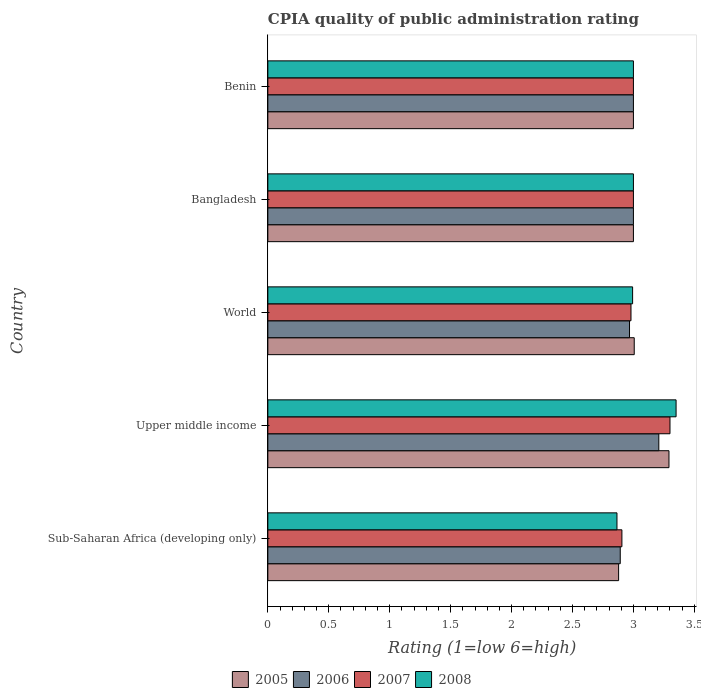Are the number of bars per tick equal to the number of legend labels?
Give a very brief answer. Yes. How many bars are there on the 5th tick from the bottom?
Offer a very short reply. 4. What is the label of the 4th group of bars from the top?
Give a very brief answer. Upper middle income. What is the CPIA rating in 2008 in Sub-Saharan Africa (developing only)?
Offer a terse response. 2.86. Across all countries, what is the maximum CPIA rating in 2005?
Your answer should be very brief. 3.29. Across all countries, what is the minimum CPIA rating in 2008?
Ensure brevity in your answer.  2.86. In which country was the CPIA rating in 2008 maximum?
Ensure brevity in your answer.  Upper middle income. In which country was the CPIA rating in 2005 minimum?
Provide a succinct answer. Sub-Saharan Africa (developing only). What is the total CPIA rating in 2008 in the graph?
Your answer should be compact. 15.21. What is the difference between the CPIA rating in 2005 in Bangladesh and that in Sub-Saharan Africa (developing only)?
Make the answer very short. 0.12. What is the difference between the CPIA rating in 2005 in Sub-Saharan Africa (developing only) and the CPIA rating in 2006 in Benin?
Give a very brief answer. -0.12. What is the average CPIA rating in 2005 per country?
Make the answer very short. 3.04. What is the difference between the CPIA rating in 2006 and CPIA rating in 2008 in Bangladesh?
Offer a very short reply. 0. What is the ratio of the CPIA rating in 2005 in Bangladesh to that in World?
Keep it short and to the point. 1. What is the difference between the highest and the second highest CPIA rating in 2005?
Your answer should be compact. 0.29. What is the difference between the highest and the lowest CPIA rating in 2007?
Keep it short and to the point. 0.39. In how many countries, is the CPIA rating in 2006 greater than the average CPIA rating in 2006 taken over all countries?
Give a very brief answer. 1. Is it the case that in every country, the sum of the CPIA rating in 2008 and CPIA rating in 2007 is greater than the sum of CPIA rating in 2005 and CPIA rating in 2006?
Keep it short and to the point. No. What does the 3rd bar from the bottom in Benin represents?
Give a very brief answer. 2007. Are all the bars in the graph horizontal?
Your answer should be very brief. Yes. How many countries are there in the graph?
Ensure brevity in your answer.  5. Does the graph contain grids?
Give a very brief answer. No. How are the legend labels stacked?
Provide a short and direct response. Horizontal. What is the title of the graph?
Provide a short and direct response. CPIA quality of public administration rating. What is the label or title of the X-axis?
Offer a terse response. Rating (1=low 6=high). What is the label or title of the Y-axis?
Offer a terse response. Country. What is the Rating (1=low 6=high) of 2005 in Sub-Saharan Africa (developing only)?
Make the answer very short. 2.88. What is the Rating (1=low 6=high) in 2006 in Sub-Saharan Africa (developing only)?
Your answer should be very brief. 2.89. What is the Rating (1=low 6=high) of 2007 in Sub-Saharan Africa (developing only)?
Offer a terse response. 2.91. What is the Rating (1=low 6=high) in 2008 in Sub-Saharan Africa (developing only)?
Provide a succinct answer. 2.86. What is the Rating (1=low 6=high) in 2005 in Upper middle income?
Your response must be concise. 3.29. What is the Rating (1=low 6=high) in 2006 in Upper middle income?
Your answer should be very brief. 3.21. What is the Rating (1=low 6=high) of 2007 in Upper middle income?
Ensure brevity in your answer.  3.3. What is the Rating (1=low 6=high) in 2008 in Upper middle income?
Provide a succinct answer. 3.35. What is the Rating (1=low 6=high) in 2005 in World?
Your answer should be very brief. 3.01. What is the Rating (1=low 6=high) of 2006 in World?
Offer a very short reply. 2.97. What is the Rating (1=low 6=high) in 2007 in World?
Your response must be concise. 2.98. What is the Rating (1=low 6=high) in 2008 in World?
Ensure brevity in your answer.  2.99. What is the Rating (1=low 6=high) of 2006 in Bangladesh?
Your answer should be compact. 3. What is the Rating (1=low 6=high) in 2005 in Benin?
Your response must be concise. 3. What is the Rating (1=low 6=high) of 2007 in Benin?
Your answer should be compact. 3. What is the Rating (1=low 6=high) of 2008 in Benin?
Provide a succinct answer. 3. Across all countries, what is the maximum Rating (1=low 6=high) of 2005?
Provide a short and direct response. 3.29. Across all countries, what is the maximum Rating (1=low 6=high) in 2006?
Provide a short and direct response. 3.21. Across all countries, what is the maximum Rating (1=low 6=high) of 2008?
Provide a succinct answer. 3.35. Across all countries, what is the minimum Rating (1=low 6=high) of 2005?
Provide a short and direct response. 2.88. Across all countries, what is the minimum Rating (1=low 6=high) in 2006?
Ensure brevity in your answer.  2.89. Across all countries, what is the minimum Rating (1=low 6=high) in 2007?
Offer a terse response. 2.91. Across all countries, what is the minimum Rating (1=low 6=high) in 2008?
Your answer should be compact. 2.86. What is the total Rating (1=low 6=high) in 2005 in the graph?
Offer a very short reply. 15.18. What is the total Rating (1=low 6=high) in 2006 in the graph?
Your answer should be compact. 15.07. What is the total Rating (1=low 6=high) in 2007 in the graph?
Keep it short and to the point. 15.19. What is the total Rating (1=low 6=high) of 2008 in the graph?
Make the answer very short. 15.21. What is the difference between the Rating (1=low 6=high) of 2005 in Sub-Saharan Africa (developing only) and that in Upper middle income?
Your answer should be compact. -0.41. What is the difference between the Rating (1=low 6=high) of 2006 in Sub-Saharan Africa (developing only) and that in Upper middle income?
Your answer should be very brief. -0.32. What is the difference between the Rating (1=low 6=high) of 2007 in Sub-Saharan Africa (developing only) and that in Upper middle income?
Provide a short and direct response. -0.39. What is the difference between the Rating (1=low 6=high) of 2008 in Sub-Saharan Africa (developing only) and that in Upper middle income?
Your answer should be compact. -0.49. What is the difference between the Rating (1=low 6=high) of 2005 in Sub-Saharan Africa (developing only) and that in World?
Your answer should be very brief. -0.13. What is the difference between the Rating (1=low 6=high) in 2006 in Sub-Saharan Africa (developing only) and that in World?
Your answer should be compact. -0.08. What is the difference between the Rating (1=low 6=high) in 2007 in Sub-Saharan Africa (developing only) and that in World?
Your answer should be very brief. -0.07. What is the difference between the Rating (1=low 6=high) of 2008 in Sub-Saharan Africa (developing only) and that in World?
Offer a very short reply. -0.13. What is the difference between the Rating (1=low 6=high) of 2005 in Sub-Saharan Africa (developing only) and that in Bangladesh?
Your answer should be very brief. -0.12. What is the difference between the Rating (1=low 6=high) in 2006 in Sub-Saharan Africa (developing only) and that in Bangladesh?
Provide a short and direct response. -0.11. What is the difference between the Rating (1=low 6=high) of 2007 in Sub-Saharan Africa (developing only) and that in Bangladesh?
Offer a very short reply. -0.09. What is the difference between the Rating (1=low 6=high) in 2008 in Sub-Saharan Africa (developing only) and that in Bangladesh?
Your answer should be very brief. -0.14. What is the difference between the Rating (1=low 6=high) in 2005 in Sub-Saharan Africa (developing only) and that in Benin?
Make the answer very short. -0.12. What is the difference between the Rating (1=low 6=high) in 2006 in Sub-Saharan Africa (developing only) and that in Benin?
Offer a very short reply. -0.11. What is the difference between the Rating (1=low 6=high) of 2007 in Sub-Saharan Africa (developing only) and that in Benin?
Offer a very short reply. -0.09. What is the difference between the Rating (1=low 6=high) in 2008 in Sub-Saharan Africa (developing only) and that in Benin?
Your response must be concise. -0.14. What is the difference between the Rating (1=low 6=high) of 2005 in Upper middle income and that in World?
Your answer should be very brief. 0.29. What is the difference between the Rating (1=low 6=high) of 2006 in Upper middle income and that in World?
Provide a succinct answer. 0.24. What is the difference between the Rating (1=low 6=high) in 2007 in Upper middle income and that in World?
Make the answer very short. 0.32. What is the difference between the Rating (1=low 6=high) of 2008 in Upper middle income and that in World?
Give a very brief answer. 0.36. What is the difference between the Rating (1=low 6=high) of 2005 in Upper middle income and that in Bangladesh?
Make the answer very short. 0.29. What is the difference between the Rating (1=low 6=high) in 2006 in Upper middle income and that in Bangladesh?
Your answer should be compact. 0.21. What is the difference between the Rating (1=low 6=high) in 2008 in Upper middle income and that in Bangladesh?
Provide a succinct answer. 0.35. What is the difference between the Rating (1=low 6=high) of 2005 in Upper middle income and that in Benin?
Your answer should be compact. 0.29. What is the difference between the Rating (1=low 6=high) in 2006 in Upper middle income and that in Benin?
Ensure brevity in your answer.  0.21. What is the difference between the Rating (1=low 6=high) of 2008 in Upper middle income and that in Benin?
Your answer should be compact. 0.35. What is the difference between the Rating (1=low 6=high) of 2005 in World and that in Bangladesh?
Your response must be concise. 0.01. What is the difference between the Rating (1=low 6=high) in 2006 in World and that in Bangladesh?
Keep it short and to the point. -0.03. What is the difference between the Rating (1=low 6=high) in 2007 in World and that in Bangladesh?
Offer a terse response. -0.02. What is the difference between the Rating (1=low 6=high) of 2008 in World and that in Bangladesh?
Your answer should be very brief. -0.01. What is the difference between the Rating (1=low 6=high) of 2005 in World and that in Benin?
Make the answer very short. 0.01. What is the difference between the Rating (1=low 6=high) in 2006 in World and that in Benin?
Your answer should be compact. -0.03. What is the difference between the Rating (1=low 6=high) of 2007 in World and that in Benin?
Your answer should be very brief. -0.02. What is the difference between the Rating (1=low 6=high) in 2008 in World and that in Benin?
Give a very brief answer. -0.01. What is the difference between the Rating (1=low 6=high) in 2006 in Bangladesh and that in Benin?
Provide a short and direct response. 0. What is the difference between the Rating (1=low 6=high) of 2005 in Sub-Saharan Africa (developing only) and the Rating (1=low 6=high) of 2006 in Upper middle income?
Offer a terse response. -0.33. What is the difference between the Rating (1=low 6=high) in 2005 in Sub-Saharan Africa (developing only) and the Rating (1=low 6=high) in 2007 in Upper middle income?
Give a very brief answer. -0.42. What is the difference between the Rating (1=low 6=high) in 2005 in Sub-Saharan Africa (developing only) and the Rating (1=low 6=high) in 2008 in Upper middle income?
Offer a very short reply. -0.47. What is the difference between the Rating (1=low 6=high) of 2006 in Sub-Saharan Africa (developing only) and the Rating (1=low 6=high) of 2007 in Upper middle income?
Offer a very short reply. -0.41. What is the difference between the Rating (1=low 6=high) in 2006 in Sub-Saharan Africa (developing only) and the Rating (1=low 6=high) in 2008 in Upper middle income?
Your answer should be very brief. -0.46. What is the difference between the Rating (1=low 6=high) of 2007 in Sub-Saharan Africa (developing only) and the Rating (1=low 6=high) of 2008 in Upper middle income?
Provide a short and direct response. -0.44. What is the difference between the Rating (1=low 6=high) of 2005 in Sub-Saharan Africa (developing only) and the Rating (1=low 6=high) of 2006 in World?
Offer a very short reply. -0.09. What is the difference between the Rating (1=low 6=high) of 2005 in Sub-Saharan Africa (developing only) and the Rating (1=low 6=high) of 2007 in World?
Offer a very short reply. -0.1. What is the difference between the Rating (1=low 6=high) in 2005 in Sub-Saharan Africa (developing only) and the Rating (1=low 6=high) in 2008 in World?
Keep it short and to the point. -0.12. What is the difference between the Rating (1=low 6=high) of 2006 in Sub-Saharan Africa (developing only) and the Rating (1=low 6=high) of 2007 in World?
Provide a succinct answer. -0.09. What is the difference between the Rating (1=low 6=high) in 2006 in Sub-Saharan Africa (developing only) and the Rating (1=low 6=high) in 2008 in World?
Provide a short and direct response. -0.1. What is the difference between the Rating (1=low 6=high) in 2007 in Sub-Saharan Africa (developing only) and the Rating (1=low 6=high) in 2008 in World?
Provide a short and direct response. -0.09. What is the difference between the Rating (1=low 6=high) in 2005 in Sub-Saharan Africa (developing only) and the Rating (1=low 6=high) in 2006 in Bangladesh?
Your answer should be compact. -0.12. What is the difference between the Rating (1=low 6=high) in 2005 in Sub-Saharan Africa (developing only) and the Rating (1=low 6=high) in 2007 in Bangladesh?
Keep it short and to the point. -0.12. What is the difference between the Rating (1=low 6=high) of 2005 in Sub-Saharan Africa (developing only) and the Rating (1=low 6=high) of 2008 in Bangladesh?
Your answer should be compact. -0.12. What is the difference between the Rating (1=low 6=high) in 2006 in Sub-Saharan Africa (developing only) and the Rating (1=low 6=high) in 2007 in Bangladesh?
Your answer should be very brief. -0.11. What is the difference between the Rating (1=low 6=high) of 2006 in Sub-Saharan Africa (developing only) and the Rating (1=low 6=high) of 2008 in Bangladesh?
Offer a very short reply. -0.11. What is the difference between the Rating (1=low 6=high) of 2007 in Sub-Saharan Africa (developing only) and the Rating (1=low 6=high) of 2008 in Bangladesh?
Make the answer very short. -0.09. What is the difference between the Rating (1=low 6=high) of 2005 in Sub-Saharan Africa (developing only) and the Rating (1=low 6=high) of 2006 in Benin?
Make the answer very short. -0.12. What is the difference between the Rating (1=low 6=high) of 2005 in Sub-Saharan Africa (developing only) and the Rating (1=low 6=high) of 2007 in Benin?
Make the answer very short. -0.12. What is the difference between the Rating (1=low 6=high) in 2005 in Sub-Saharan Africa (developing only) and the Rating (1=low 6=high) in 2008 in Benin?
Your response must be concise. -0.12. What is the difference between the Rating (1=low 6=high) in 2006 in Sub-Saharan Africa (developing only) and the Rating (1=low 6=high) in 2007 in Benin?
Your answer should be compact. -0.11. What is the difference between the Rating (1=low 6=high) in 2006 in Sub-Saharan Africa (developing only) and the Rating (1=low 6=high) in 2008 in Benin?
Provide a short and direct response. -0.11. What is the difference between the Rating (1=low 6=high) in 2007 in Sub-Saharan Africa (developing only) and the Rating (1=low 6=high) in 2008 in Benin?
Give a very brief answer. -0.09. What is the difference between the Rating (1=low 6=high) of 2005 in Upper middle income and the Rating (1=low 6=high) of 2006 in World?
Your answer should be compact. 0.32. What is the difference between the Rating (1=low 6=high) of 2005 in Upper middle income and the Rating (1=low 6=high) of 2007 in World?
Provide a short and direct response. 0.31. What is the difference between the Rating (1=low 6=high) of 2005 in Upper middle income and the Rating (1=low 6=high) of 2008 in World?
Your response must be concise. 0.3. What is the difference between the Rating (1=low 6=high) in 2006 in Upper middle income and the Rating (1=low 6=high) in 2007 in World?
Ensure brevity in your answer.  0.23. What is the difference between the Rating (1=low 6=high) of 2006 in Upper middle income and the Rating (1=low 6=high) of 2008 in World?
Your answer should be very brief. 0.21. What is the difference between the Rating (1=low 6=high) of 2007 in Upper middle income and the Rating (1=low 6=high) of 2008 in World?
Offer a terse response. 0.31. What is the difference between the Rating (1=low 6=high) in 2005 in Upper middle income and the Rating (1=low 6=high) in 2006 in Bangladesh?
Provide a short and direct response. 0.29. What is the difference between the Rating (1=low 6=high) of 2005 in Upper middle income and the Rating (1=low 6=high) of 2007 in Bangladesh?
Offer a very short reply. 0.29. What is the difference between the Rating (1=low 6=high) in 2005 in Upper middle income and the Rating (1=low 6=high) in 2008 in Bangladesh?
Give a very brief answer. 0.29. What is the difference between the Rating (1=low 6=high) of 2006 in Upper middle income and the Rating (1=low 6=high) of 2007 in Bangladesh?
Your response must be concise. 0.21. What is the difference between the Rating (1=low 6=high) of 2006 in Upper middle income and the Rating (1=low 6=high) of 2008 in Bangladesh?
Give a very brief answer. 0.21. What is the difference between the Rating (1=low 6=high) of 2005 in Upper middle income and the Rating (1=low 6=high) of 2006 in Benin?
Keep it short and to the point. 0.29. What is the difference between the Rating (1=low 6=high) in 2005 in Upper middle income and the Rating (1=low 6=high) in 2007 in Benin?
Provide a succinct answer. 0.29. What is the difference between the Rating (1=low 6=high) in 2005 in Upper middle income and the Rating (1=low 6=high) in 2008 in Benin?
Provide a succinct answer. 0.29. What is the difference between the Rating (1=low 6=high) of 2006 in Upper middle income and the Rating (1=low 6=high) of 2007 in Benin?
Your answer should be compact. 0.21. What is the difference between the Rating (1=low 6=high) of 2006 in Upper middle income and the Rating (1=low 6=high) of 2008 in Benin?
Offer a very short reply. 0.21. What is the difference between the Rating (1=low 6=high) of 2007 in Upper middle income and the Rating (1=low 6=high) of 2008 in Benin?
Give a very brief answer. 0.3. What is the difference between the Rating (1=low 6=high) of 2005 in World and the Rating (1=low 6=high) of 2006 in Bangladesh?
Give a very brief answer. 0.01. What is the difference between the Rating (1=low 6=high) in 2005 in World and the Rating (1=low 6=high) in 2007 in Bangladesh?
Provide a succinct answer. 0.01. What is the difference between the Rating (1=low 6=high) of 2005 in World and the Rating (1=low 6=high) of 2008 in Bangladesh?
Your response must be concise. 0.01. What is the difference between the Rating (1=low 6=high) of 2006 in World and the Rating (1=low 6=high) of 2007 in Bangladesh?
Your answer should be very brief. -0.03. What is the difference between the Rating (1=low 6=high) in 2006 in World and the Rating (1=low 6=high) in 2008 in Bangladesh?
Ensure brevity in your answer.  -0.03. What is the difference between the Rating (1=low 6=high) of 2007 in World and the Rating (1=low 6=high) of 2008 in Bangladesh?
Offer a very short reply. -0.02. What is the difference between the Rating (1=low 6=high) of 2005 in World and the Rating (1=low 6=high) of 2006 in Benin?
Your response must be concise. 0.01. What is the difference between the Rating (1=low 6=high) of 2005 in World and the Rating (1=low 6=high) of 2007 in Benin?
Your response must be concise. 0.01. What is the difference between the Rating (1=low 6=high) in 2005 in World and the Rating (1=low 6=high) in 2008 in Benin?
Keep it short and to the point. 0.01. What is the difference between the Rating (1=low 6=high) in 2006 in World and the Rating (1=low 6=high) in 2007 in Benin?
Keep it short and to the point. -0.03. What is the difference between the Rating (1=low 6=high) of 2006 in World and the Rating (1=low 6=high) of 2008 in Benin?
Your response must be concise. -0.03. What is the difference between the Rating (1=low 6=high) of 2007 in World and the Rating (1=low 6=high) of 2008 in Benin?
Make the answer very short. -0.02. What is the difference between the Rating (1=low 6=high) of 2005 in Bangladesh and the Rating (1=low 6=high) of 2006 in Benin?
Keep it short and to the point. 0. What is the difference between the Rating (1=low 6=high) of 2005 in Bangladesh and the Rating (1=low 6=high) of 2008 in Benin?
Offer a terse response. 0. What is the difference between the Rating (1=low 6=high) of 2007 in Bangladesh and the Rating (1=low 6=high) of 2008 in Benin?
Offer a very short reply. 0. What is the average Rating (1=low 6=high) in 2005 per country?
Your answer should be compact. 3.04. What is the average Rating (1=low 6=high) of 2006 per country?
Give a very brief answer. 3.01. What is the average Rating (1=low 6=high) in 2007 per country?
Keep it short and to the point. 3.04. What is the average Rating (1=low 6=high) in 2008 per country?
Provide a short and direct response. 3.04. What is the difference between the Rating (1=low 6=high) in 2005 and Rating (1=low 6=high) in 2006 in Sub-Saharan Africa (developing only)?
Keep it short and to the point. -0.01. What is the difference between the Rating (1=low 6=high) in 2005 and Rating (1=low 6=high) in 2007 in Sub-Saharan Africa (developing only)?
Offer a very short reply. -0.03. What is the difference between the Rating (1=low 6=high) of 2005 and Rating (1=low 6=high) of 2008 in Sub-Saharan Africa (developing only)?
Your response must be concise. 0.01. What is the difference between the Rating (1=low 6=high) of 2006 and Rating (1=low 6=high) of 2007 in Sub-Saharan Africa (developing only)?
Make the answer very short. -0.01. What is the difference between the Rating (1=low 6=high) in 2006 and Rating (1=low 6=high) in 2008 in Sub-Saharan Africa (developing only)?
Keep it short and to the point. 0.03. What is the difference between the Rating (1=low 6=high) in 2007 and Rating (1=low 6=high) in 2008 in Sub-Saharan Africa (developing only)?
Provide a short and direct response. 0.04. What is the difference between the Rating (1=low 6=high) in 2005 and Rating (1=low 6=high) in 2006 in Upper middle income?
Your answer should be very brief. 0.08. What is the difference between the Rating (1=low 6=high) of 2005 and Rating (1=low 6=high) of 2007 in Upper middle income?
Your answer should be compact. -0.01. What is the difference between the Rating (1=low 6=high) of 2005 and Rating (1=low 6=high) of 2008 in Upper middle income?
Keep it short and to the point. -0.06. What is the difference between the Rating (1=low 6=high) in 2006 and Rating (1=low 6=high) in 2007 in Upper middle income?
Offer a very short reply. -0.09. What is the difference between the Rating (1=low 6=high) in 2006 and Rating (1=low 6=high) in 2008 in Upper middle income?
Give a very brief answer. -0.14. What is the difference between the Rating (1=low 6=high) in 2007 and Rating (1=low 6=high) in 2008 in Upper middle income?
Provide a short and direct response. -0.05. What is the difference between the Rating (1=low 6=high) of 2005 and Rating (1=low 6=high) of 2006 in World?
Give a very brief answer. 0.04. What is the difference between the Rating (1=low 6=high) of 2005 and Rating (1=low 6=high) of 2007 in World?
Your response must be concise. 0.03. What is the difference between the Rating (1=low 6=high) of 2005 and Rating (1=low 6=high) of 2008 in World?
Give a very brief answer. 0.01. What is the difference between the Rating (1=low 6=high) in 2006 and Rating (1=low 6=high) in 2007 in World?
Ensure brevity in your answer.  -0.01. What is the difference between the Rating (1=low 6=high) of 2006 and Rating (1=low 6=high) of 2008 in World?
Your answer should be compact. -0.03. What is the difference between the Rating (1=low 6=high) of 2007 and Rating (1=low 6=high) of 2008 in World?
Keep it short and to the point. -0.01. What is the difference between the Rating (1=low 6=high) in 2005 and Rating (1=low 6=high) in 2006 in Bangladesh?
Your response must be concise. 0. What is the difference between the Rating (1=low 6=high) of 2005 and Rating (1=low 6=high) of 2008 in Bangladesh?
Provide a short and direct response. 0. What is the difference between the Rating (1=low 6=high) in 2006 and Rating (1=low 6=high) in 2007 in Bangladesh?
Your response must be concise. 0. What is the difference between the Rating (1=low 6=high) in 2006 and Rating (1=low 6=high) in 2008 in Bangladesh?
Ensure brevity in your answer.  0. What is the difference between the Rating (1=low 6=high) in 2005 and Rating (1=low 6=high) in 2006 in Benin?
Provide a short and direct response. 0. What is the difference between the Rating (1=low 6=high) of 2005 and Rating (1=low 6=high) of 2007 in Benin?
Offer a very short reply. 0. What is the ratio of the Rating (1=low 6=high) in 2005 in Sub-Saharan Africa (developing only) to that in Upper middle income?
Your response must be concise. 0.87. What is the ratio of the Rating (1=low 6=high) in 2006 in Sub-Saharan Africa (developing only) to that in Upper middle income?
Your response must be concise. 0.9. What is the ratio of the Rating (1=low 6=high) in 2007 in Sub-Saharan Africa (developing only) to that in Upper middle income?
Provide a succinct answer. 0.88. What is the ratio of the Rating (1=low 6=high) in 2008 in Sub-Saharan Africa (developing only) to that in Upper middle income?
Provide a short and direct response. 0.86. What is the ratio of the Rating (1=low 6=high) of 2005 in Sub-Saharan Africa (developing only) to that in World?
Provide a succinct answer. 0.96. What is the ratio of the Rating (1=low 6=high) in 2006 in Sub-Saharan Africa (developing only) to that in World?
Offer a very short reply. 0.97. What is the ratio of the Rating (1=low 6=high) in 2008 in Sub-Saharan Africa (developing only) to that in World?
Your answer should be compact. 0.96. What is the ratio of the Rating (1=low 6=high) of 2005 in Sub-Saharan Africa (developing only) to that in Bangladesh?
Offer a terse response. 0.96. What is the ratio of the Rating (1=low 6=high) of 2006 in Sub-Saharan Africa (developing only) to that in Bangladesh?
Give a very brief answer. 0.96. What is the ratio of the Rating (1=low 6=high) in 2007 in Sub-Saharan Africa (developing only) to that in Bangladesh?
Provide a short and direct response. 0.97. What is the ratio of the Rating (1=low 6=high) of 2008 in Sub-Saharan Africa (developing only) to that in Bangladesh?
Make the answer very short. 0.95. What is the ratio of the Rating (1=low 6=high) in 2005 in Sub-Saharan Africa (developing only) to that in Benin?
Offer a very short reply. 0.96. What is the ratio of the Rating (1=low 6=high) of 2007 in Sub-Saharan Africa (developing only) to that in Benin?
Your answer should be very brief. 0.97. What is the ratio of the Rating (1=low 6=high) in 2008 in Sub-Saharan Africa (developing only) to that in Benin?
Your response must be concise. 0.95. What is the ratio of the Rating (1=low 6=high) in 2005 in Upper middle income to that in World?
Give a very brief answer. 1.09. What is the ratio of the Rating (1=low 6=high) of 2006 in Upper middle income to that in World?
Ensure brevity in your answer.  1.08. What is the ratio of the Rating (1=low 6=high) of 2007 in Upper middle income to that in World?
Ensure brevity in your answer.  1.11. What is the ratio of the Rating (1=low 6=high) in 2008 in Upper middle income to that in World?
Provide a succinct answer. 1.12. What is the ratio of the Rating (1=low 6=high) of 2005 in Upper middle income to that in Bangladesh?
Ensure brevity in your answer.  1.1. What is the ratio of the Rating (1=low 6=high) of 2006 in Upper middle income to that in Bangladesh?
Your answer should be very brief. 1.07. What is the ratio of the Rating (1=low 6=high) in 2008 in Upper middle income to that in Bangladesh?
Give a very brief answer. 1.12. What is the ratio of the Rating (1=low 6=high) in 2005 in Upper middle income to that in Benin?
Provide a short and direct response. 1.1. What is the ratio of the Rating (1=low 6=high) in 2006 in Upper middle income to that in Benin?
Keep it short and to the point. 1.07. What is the ratio of the Rating (1=low 6=high) of 2007 in Upper middle income to that in Benin?
Provide a succinct answer. 1.1. What is the ratio of the Rating (1=low 6=high) in 2008 in Upper middle income to that in Benin?
Your answer should be very brief. 1.12. What is the ratio of the Rating (1=low 6=high) of 2005 in World to that in Bangladesh?
Make the answer very short. 1. What is the ratio of the Rating (1=low 6=high) in 2006 in World to that in Bangladesh?
Ensure brevity in your answer.  0.99. What is the ratio of the Rating (1=low 6=high) in 2007 in World to that in Bangladesh?
Offer a very short reply. 0.99. What is the ratio of the Rating (1=low 6=high) in 2008 in World to that in Bangladesh?
Keep it short and to the point. 1. What is the ratio of the Rating (1=low 6=high) of 2006 in World to that in Benin?
Offer a very short reply. 0.99. What is the ratio of the Rating (1=low 6=high) of 2007 in World to that in Benin?
Your answer should be very brief. 0.99. What is the ratio of the Rating (1=low 6=high) of 2005 in Bangladesh to that in Benin?
Keep it short and to the point. 1. What is the ratio of the Rating (1=low 6=high) in 2008 in Bangladesh to that in Benin?
Your answer should be compact. 1. What is the difference between the highest and the second highest Rating (1=low 6=high) of 2005?
Your response must be concise. 0.29. What is the difference between the highest and the second highest Rating (1=low 6=high) of 2006?
Provide a succinct answer. 0.21. What is the difference between the highest and the lowest Rating (1=low 6=high) in 2005?
Keep it short and to the point. 0.41. What is the difference between the highest and the lowest Rating (1=low 6=high) of 2006?
Your answer should be compact. 0.32. What is the difference between the highest and the lowest Rating (1=low 6=high) of 2007?
Provide a succinct answer. 0.39. What is the difference between the highest and the lowest Rating (1=low 6=high) of 2008?
Offer a terse response. 0.49. 